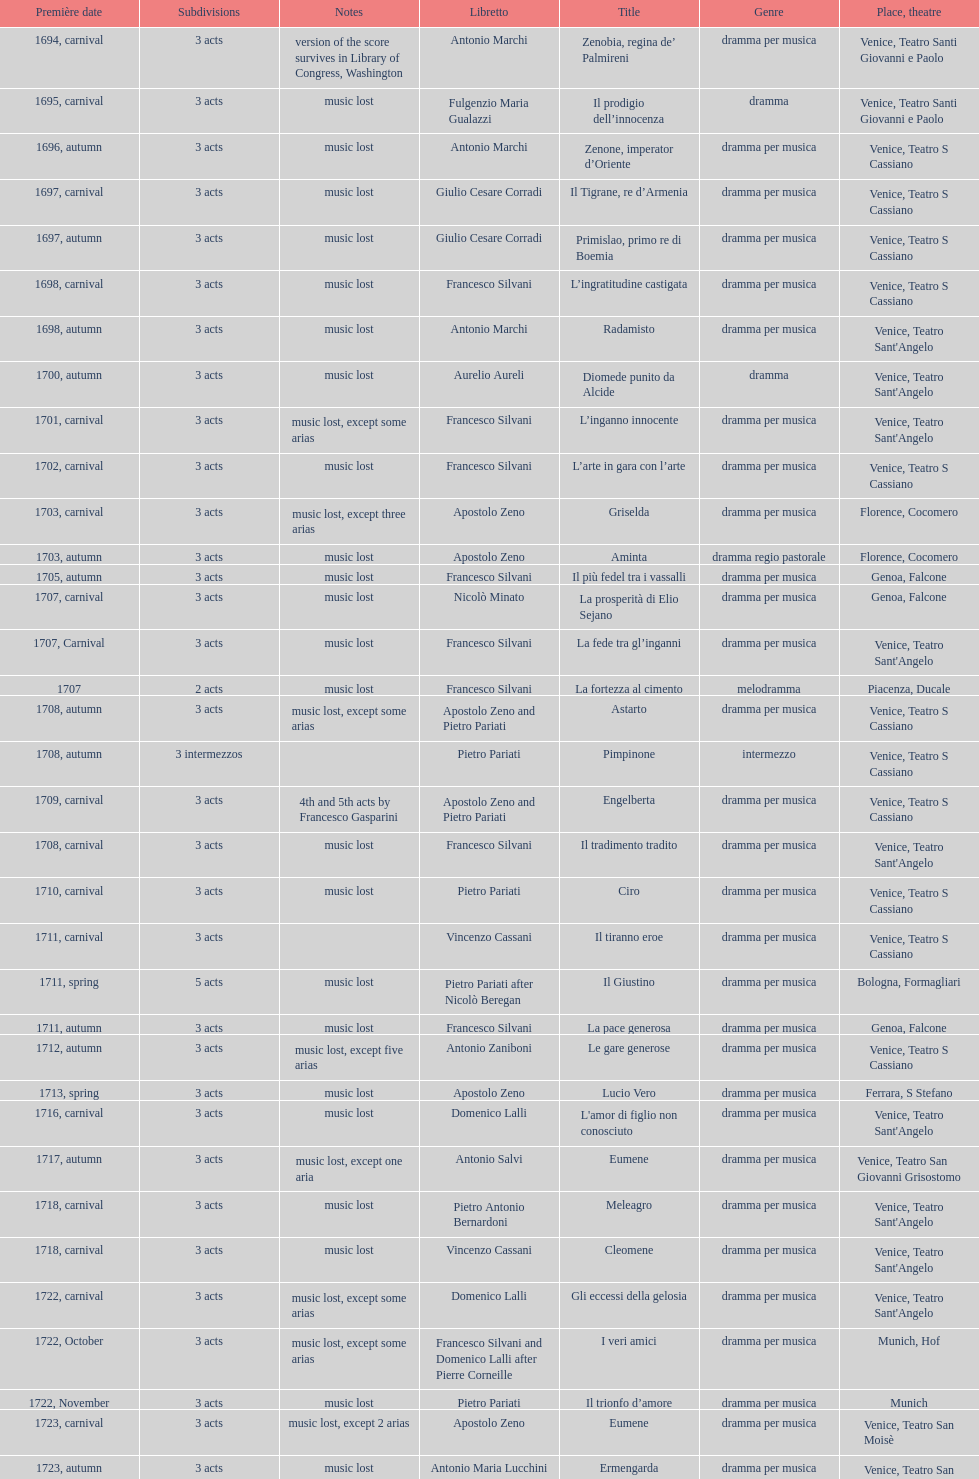Which opera has at least 5 acts? Il Giustino. 